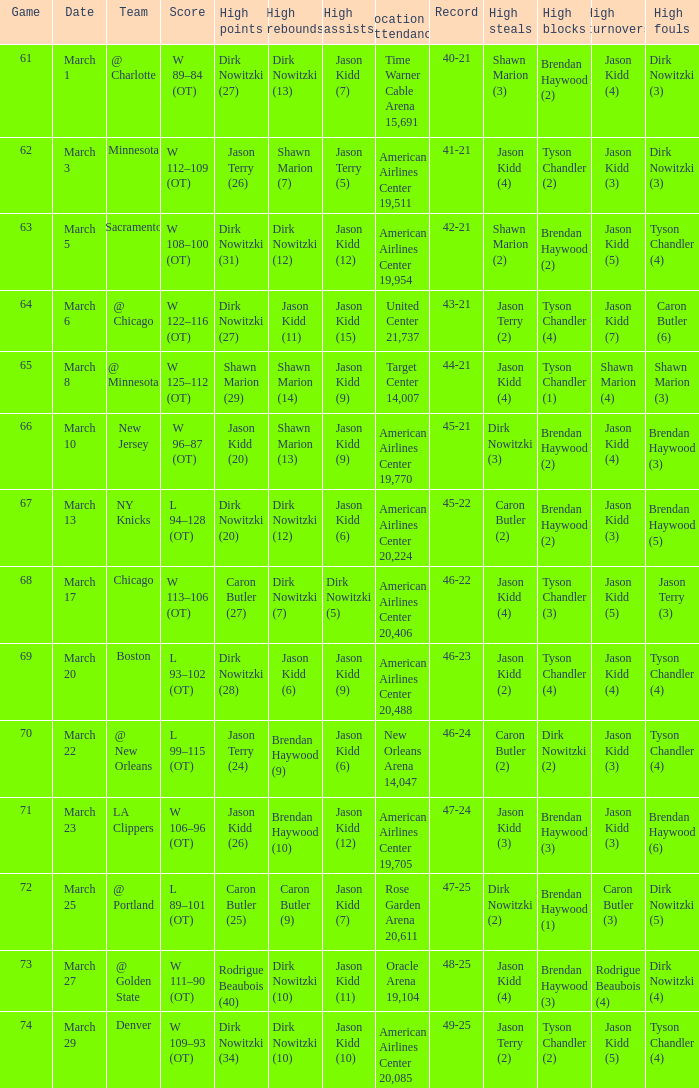List the stadium and number of people in attendance when the team record was 45-22. 1.0. 